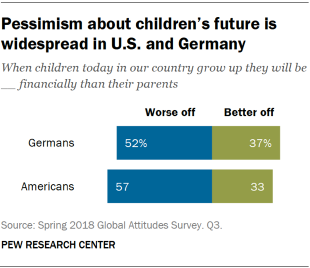Outline some significant characteristics in this image. The color commonly associated with those who are in a worse off situation is blue. The sum of the product of the value for the Worse off is 109. 